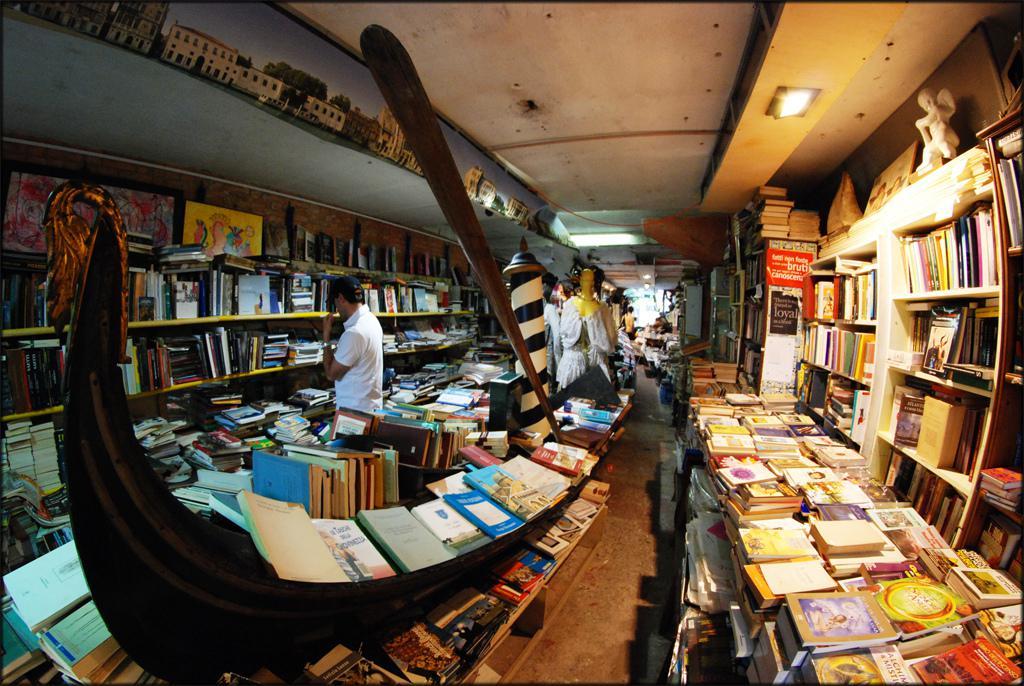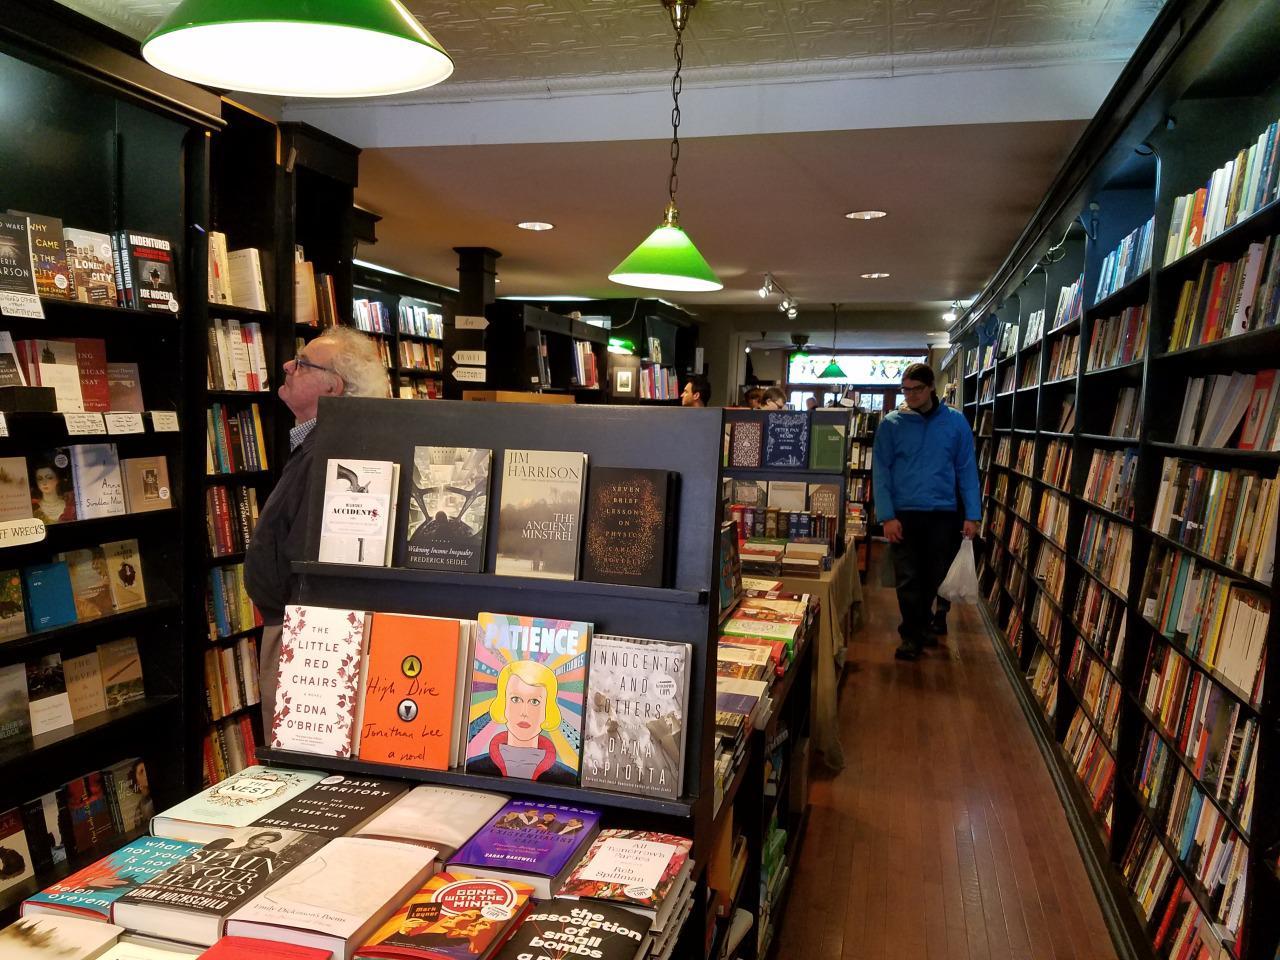The first image is the image on the left, the second image is the image on the right. For the images displayed, is the sentence "In the right image, a woman with a large handbag is framed by an opening between bookshelves." factually correct? Answer yes or no. No. The first image is the image on the left, the second image is the image on the right. Examine the images to the left and right. Is the description "At least two people are shopping for books." accurate? Answer yes or no. Yes. 